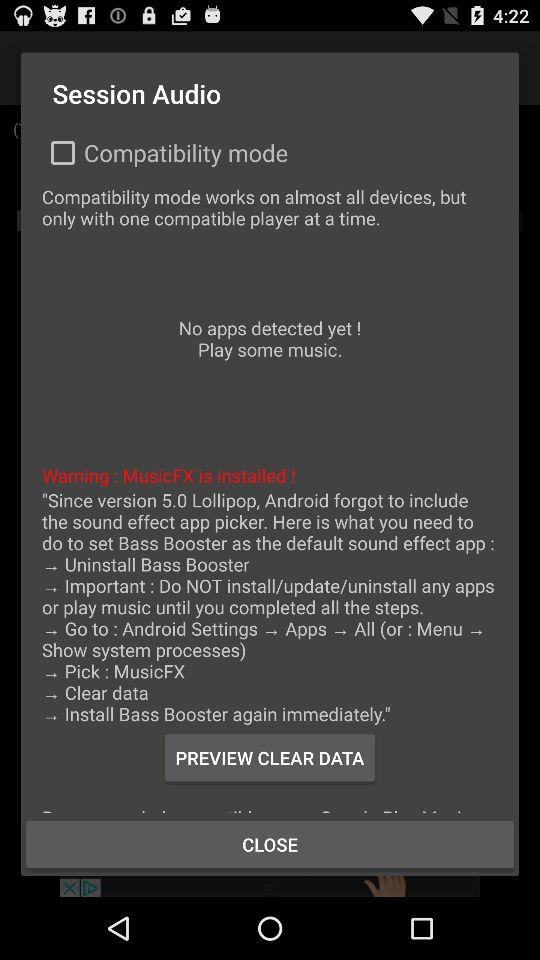How many steps does the user need to follow to set Bass Booster as the default sound effect app?
Answer the question using a single word or phrase. 6 